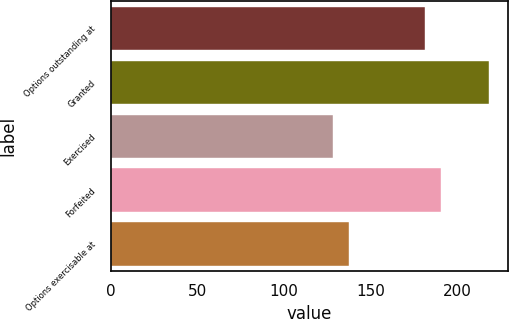Convert chart to OTSL. <chart><loc_0><loc_0><loc_500><loc_500><bar_chart><fcel>Options outstanding at<fcel>Granted<fcel>Exercised<fcel>Forfeited<fcel>Options exercisable at<nl><fcel>181.44<fcel>218.06<fcel>128.34<fcel>190.41<fcel>137.54<nl></chart> 